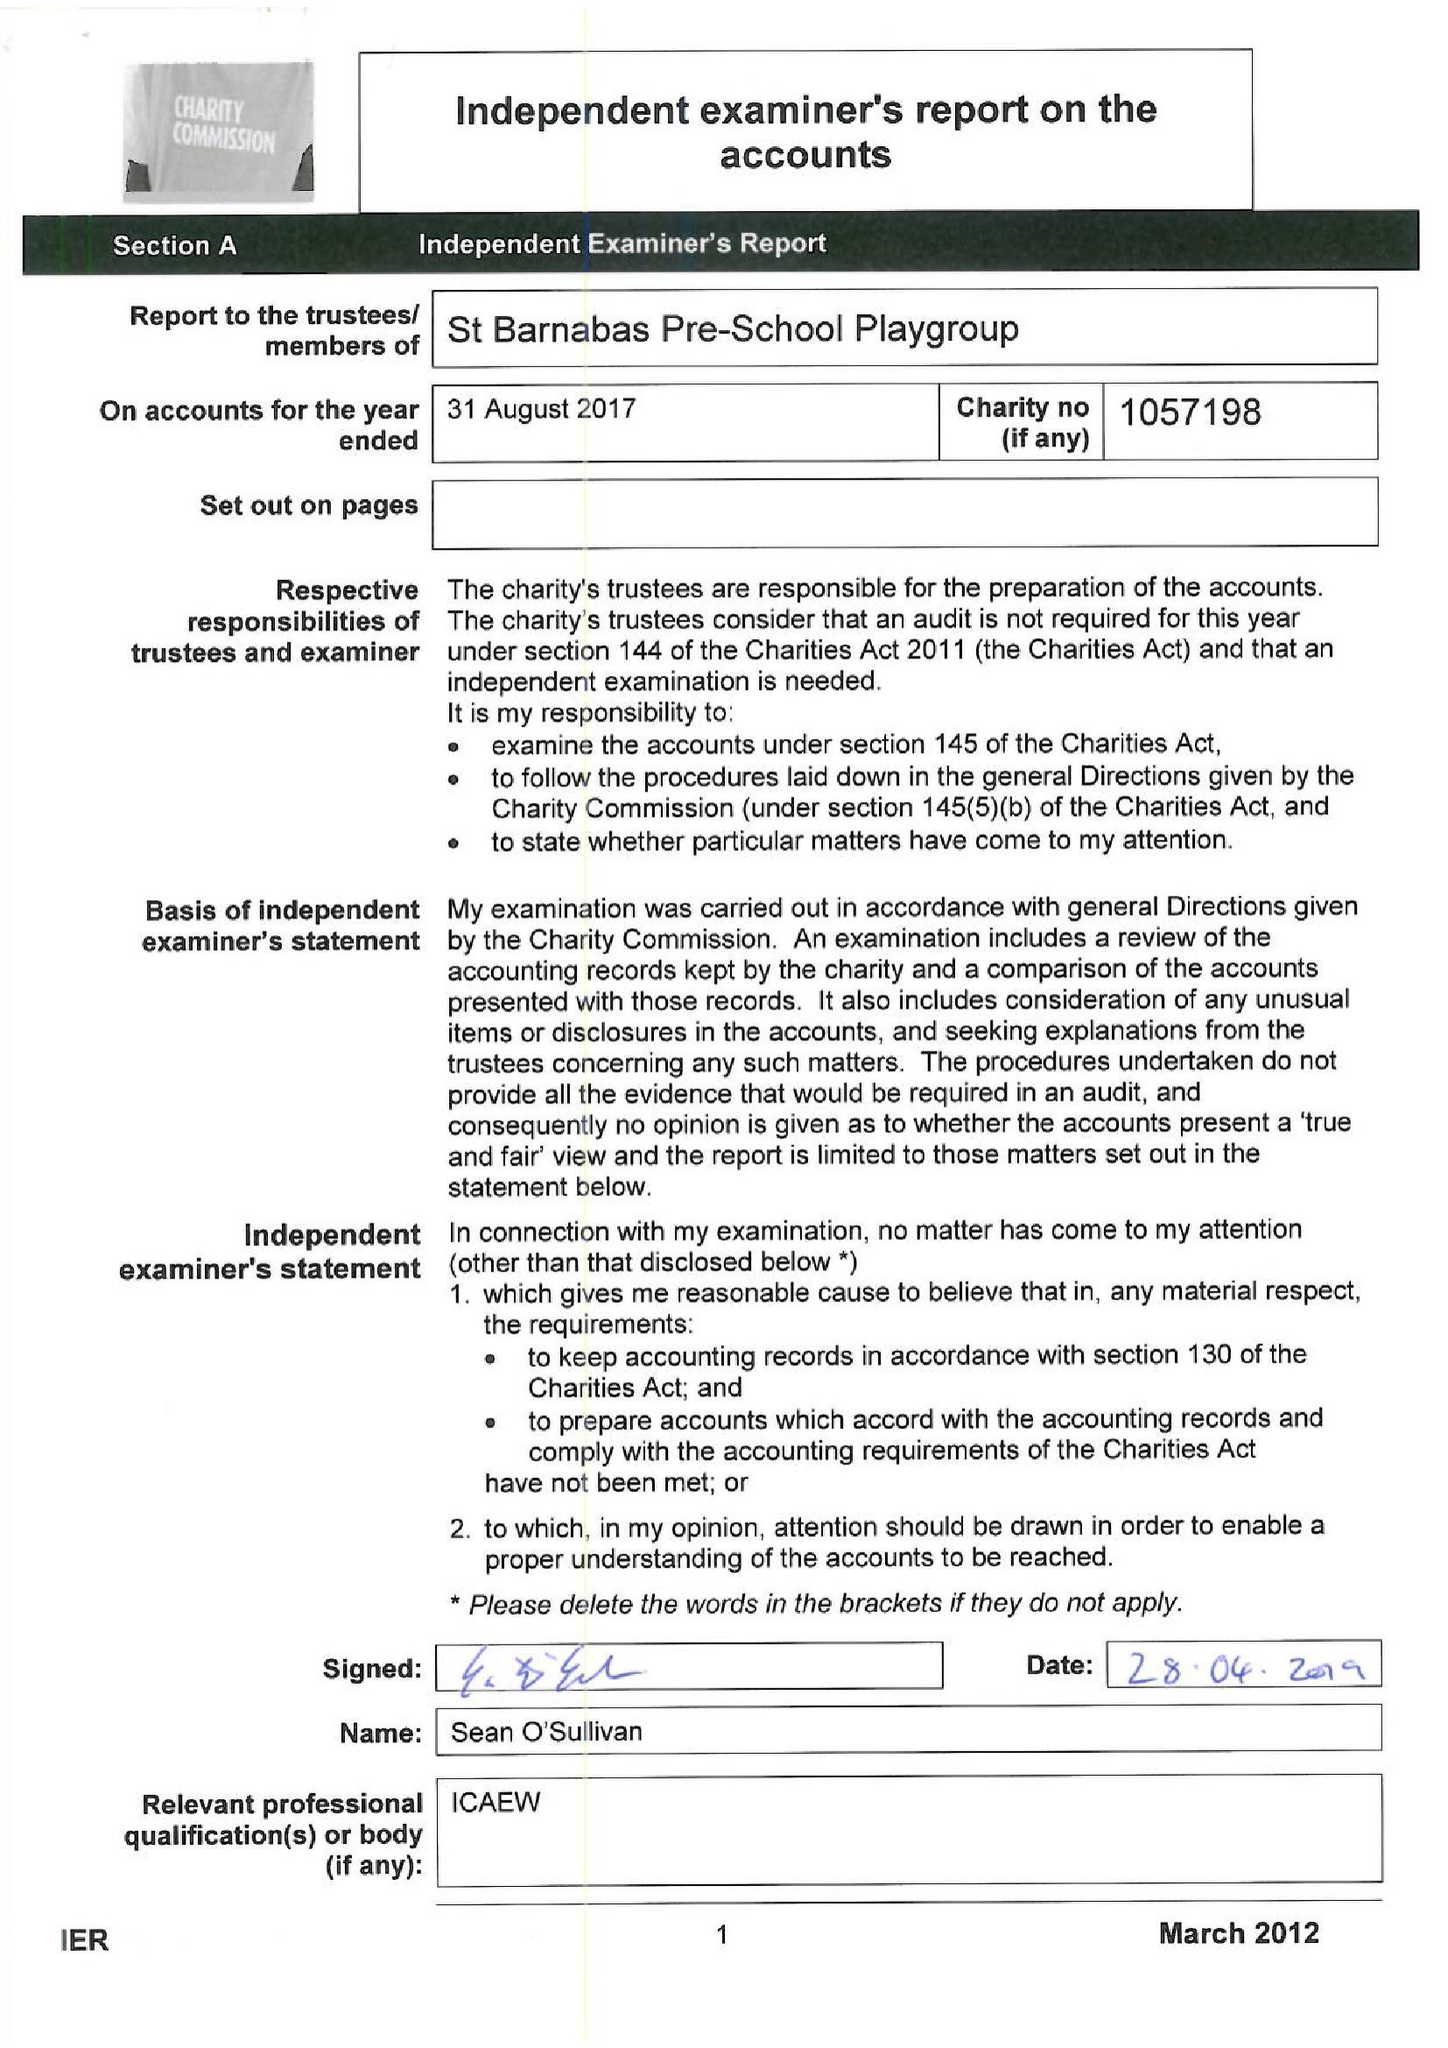What is the value for the report_date?
Answer the question using a single word or phrase. 2017-08-31 